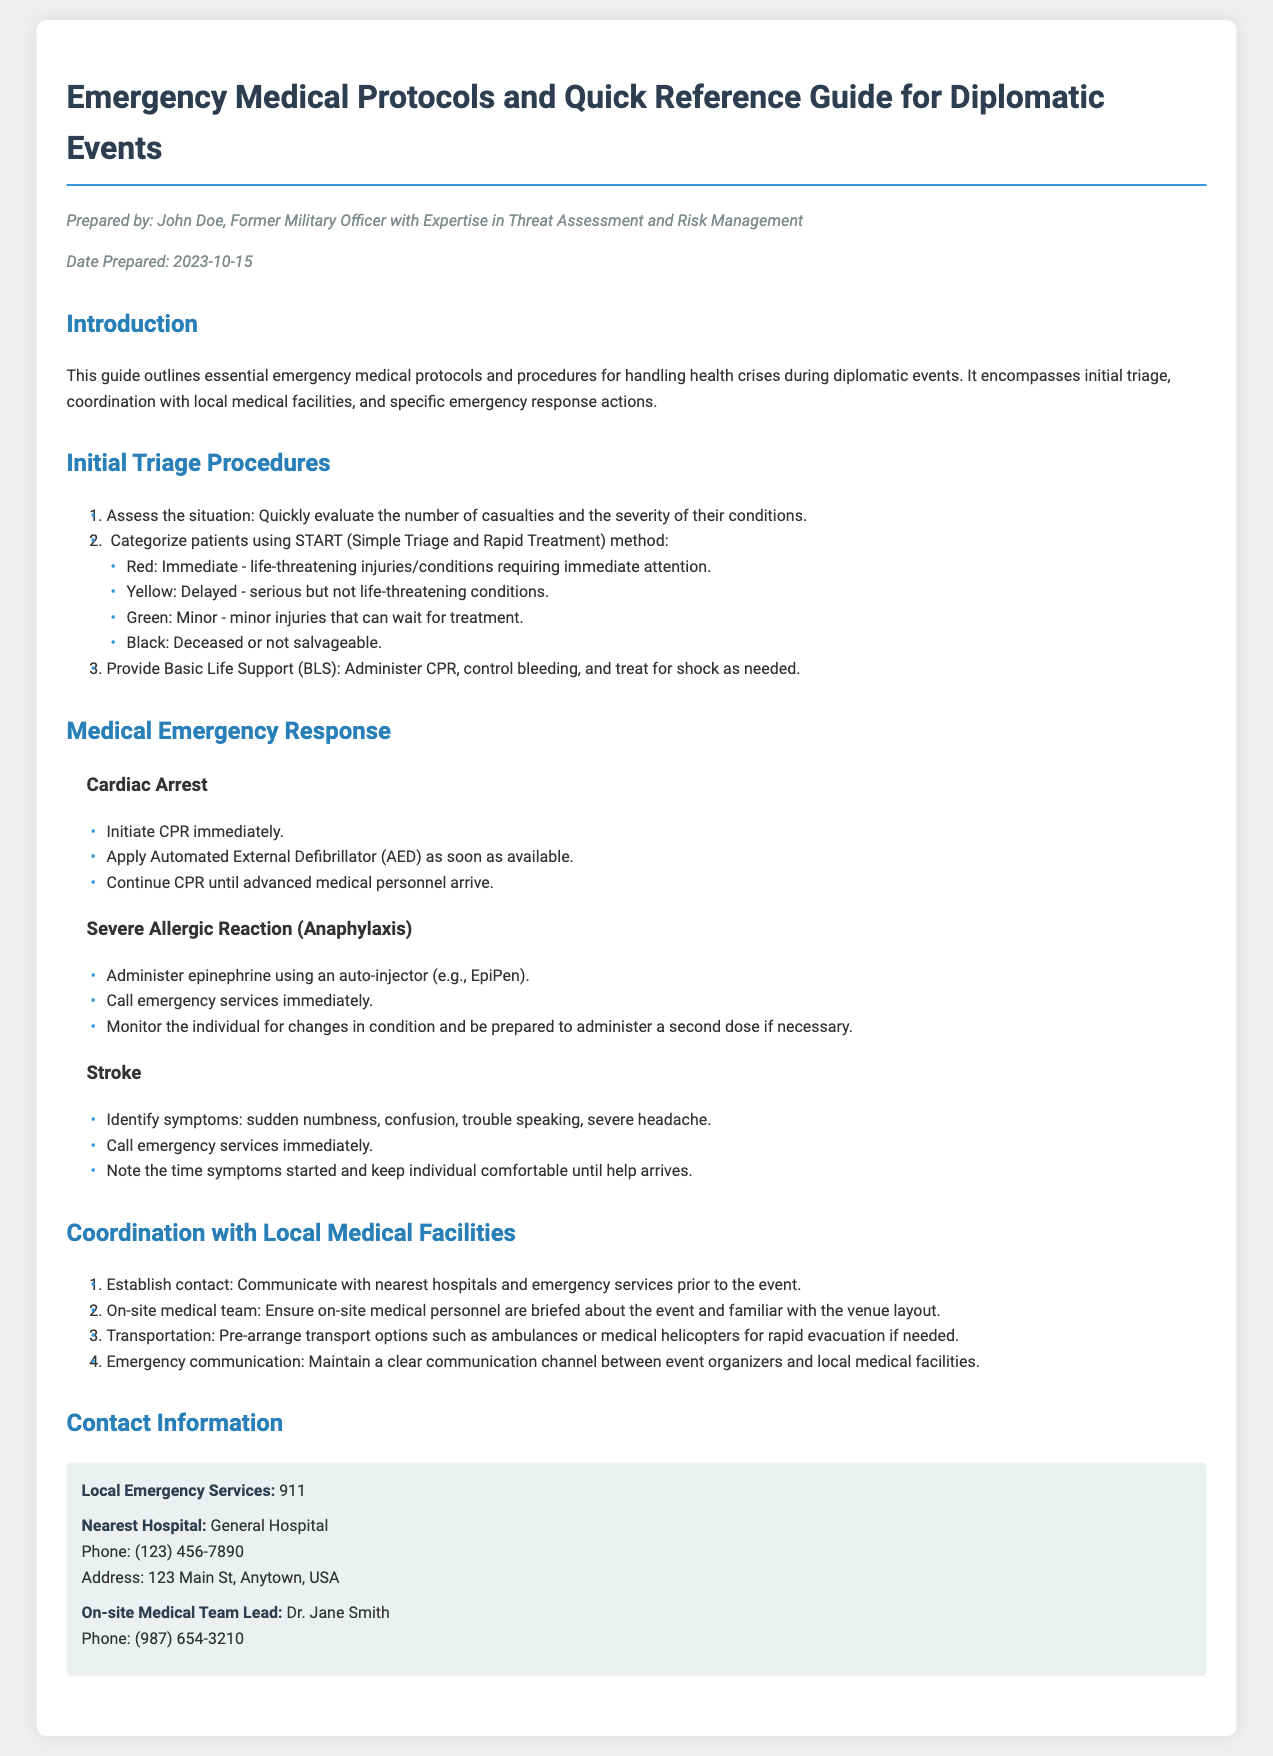what is the name of the author of the document? The document is authored by John Doe.
Answer: John Doe what is the date of preparation for the document? The document was prepared on October 15, 2023.
Answer: 2023-10-15 what is the first step in the initial triage procedures? The first step is to assess the situation.
Answer: Assess the situation what color categorizes life-threatening injuries in the START method? The color associated with life-threatening injuries is red.
Answer: Red who should be contacted for local emergency services? The document states to contact 911 for local emergency services.
Answer: 911 what is one of the symptoms to identify a stroke? A symptom of a stroke is sudden numbness.
Answer: sudden numbness how should a severe allergic reaction be treated initially? Administer epinephrine using an auto-injector (e.g., EpiPen).
Answer: Administer epinephrine what is the name of the on-site medical team lead? The on-site medical team lead is Dr. Jane Smith.
Answer: Dr. Jane Smith how many categories are there in the START method? The START method consists of four categories.
Answer: four categories 